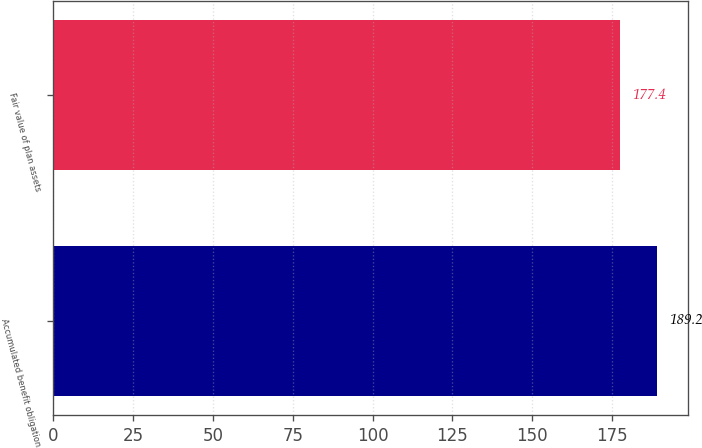Convert chart to OTSL. <chart><loc_0><loc_0><loc_500><loc_500><bar_chart><fcel>Accumulated benefit obligation<fcel>Fair value of plan assets<nl><fcel>189.2<fcel>177.4<nl></chart> 